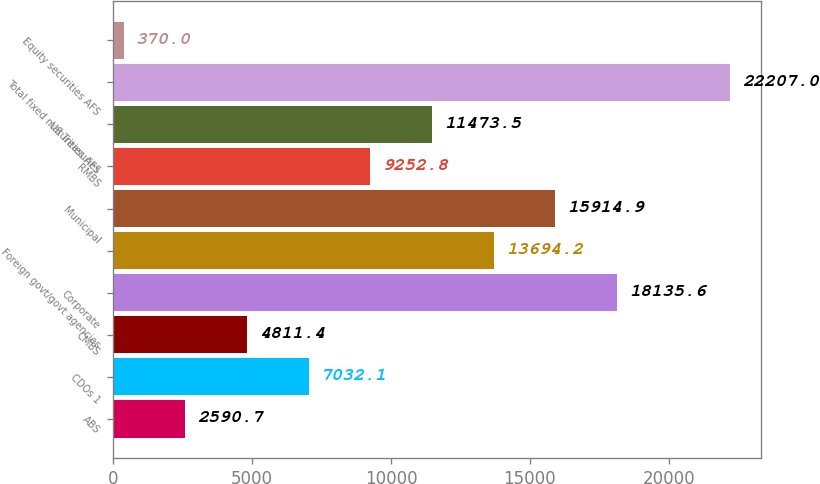Convert chart to OTSL. <chart><loc_0><loc_0><loc_500><loc_500><bar_chart><fcel>ABS<fcel>CDOs 1<fcel>CMBS<fcel>Corporate<fcel>Foreign govt/govt agencies<fcel>Municipal<fcel>RMBS<fcel>US Treasuries<fcel>Total fixed maturities AFS<fcel>Equity securities AFS<nl><fcel>2590.7<fcel>7032.1<fcel>4811.4<fcel>18135.6<fcel>13694.2<fcel>15914.9<fcel>9252.8<fcel>11473.5<fcel>22207<fcel>370<nl></chart> 